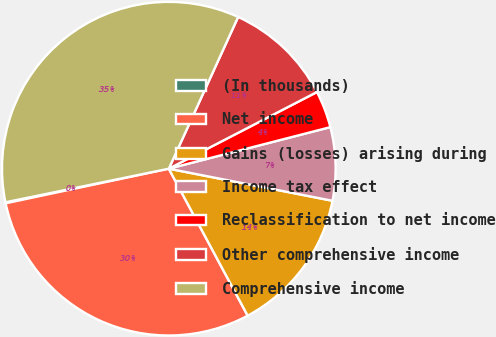Convert chart. <chart><loc_0><loc_0><loc_500><loc_500><pie_chart><fcel>(In thousands)<fcel>Net income<fcel>Gains (losses) arising during<fcel>Income tax effect<fcel>Reclassification to net income<fcel>Other comprehensive income<fcel>Comprehensive income<nl><fcel>0.1%<fcel>29.51%<fcel>14.08%<fcel>7.09%<fcel>3.59%<fcel>10.58%<fcel>35.05%<nl></chart> 